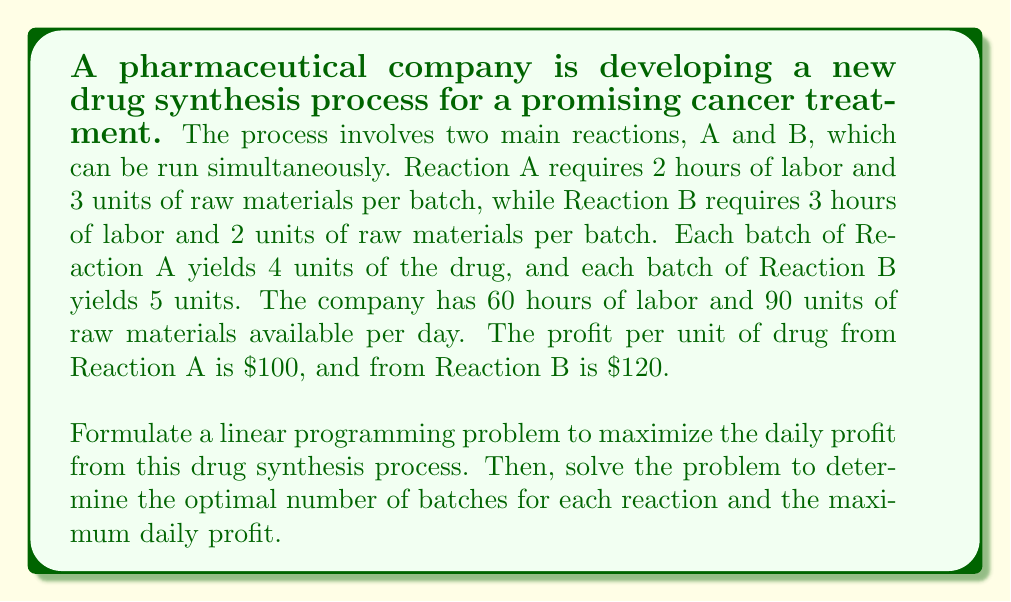Solve this math problem. Let's approach this problem step-by-step:

1) Define variables:
   Let $x$ be the number of batches of Reaction A
   Let $y$ be the number of batches of Reaction B

2) Formulate the objective function:
   Maximize profit: $Z = 400x + 600y$
   (Since each batch of A yields 4 units at $100 each, and each batch of B yields 5 units at $120 each)

3) Identify constraints:
   Labor constraint: $2x + 3y \leq 60$
   Raw material constraint: $3x + 2y \leq 90$
   Non-negativity: $x \geq 0$, $y \geq 0$

4) The complete linear programming problem:

   Maximize $Z = 400x + 600y$
   Subject to:
   $$\begin{align}
   2x + 3y &\leq 60 \\
   3x + 2y &\leq 90 \\
   x, y &\geq 0
   \end{align}$$

5) To solve this, we can use the graphical method:

   a) Plot the constraints:
      For $2x + 3y = 60$, when $x = 0$, $y = 20$; when $y = 0$, $x = 30$
      For $3x + 2y = 90$, when $x = 0$, $y = 45$; when $y = 0$, $x = 30$

   b) The feasible region is the area bounded by these lines and the axes.

   c) The corner points of the feasible region are (0,0), (0,20), (18,8), (30,0)

   d) Evaluate the objective function at each corner point:
      At (0,0): $Z = 0$
      At (0,20): $Z = 12000$
      At (18,8): $Z = 12000$
      At (30,0): $Z = 12000$

6) The maximum value occurs at (18,8), so this is our optimal solution.

Therefore, the company should produce 18 batches of Reaction A and 8 batches of Reaction B daily to maximize profit.
Answer: Optimal solution: 18 batches of Reaction A and 8 batches of Reaction B
Maximum daily profit: $12,000 